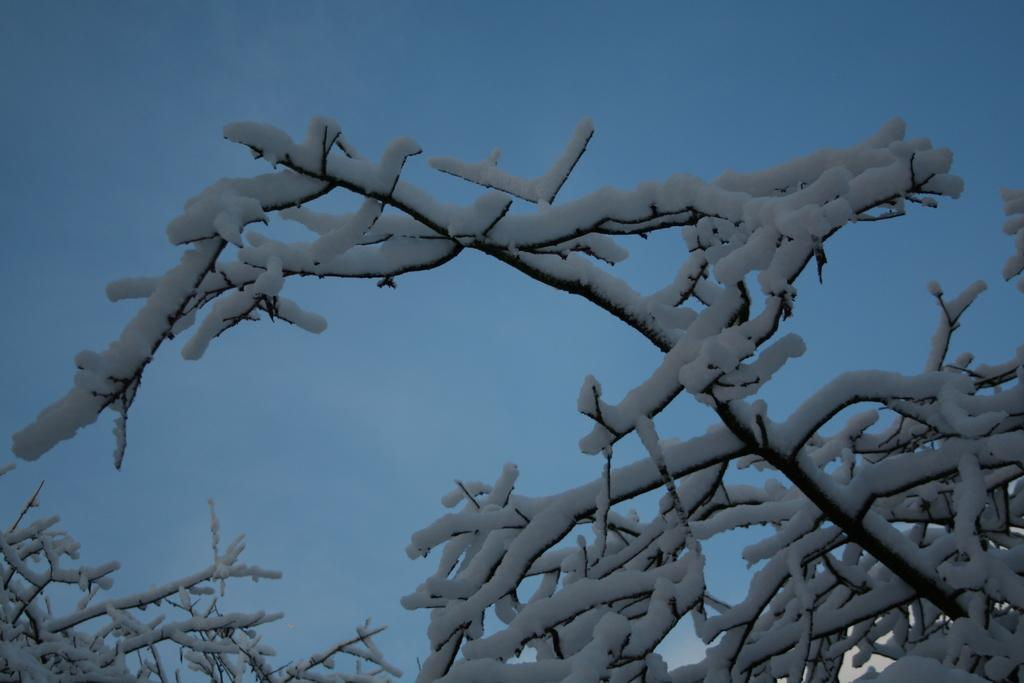What is the main object in the image? There is a tree in the image. What can be observed about the tree's structure? The tree has branches. What is covering the tree? The tree is covered with snow. What part of the natural environment is visible in the image? The sky is visible in the image. What reason did the spiders have for climbing the tree in the image? There are no spiders present in the image, so it is not possible to determine their reason for climbing the tree. 